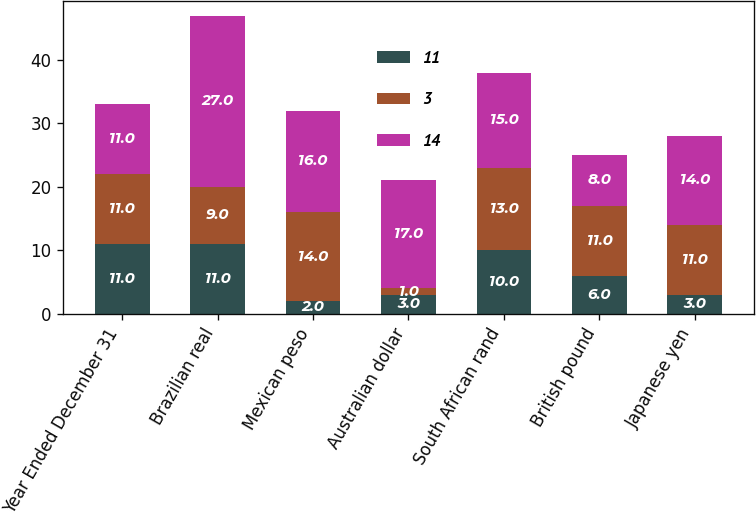Convert chart. <chart><loc_0><loc_0><loc_500><loc_500><stacked_bar_chart><ecel><fcel>Year Ended December 31<fcel>Brazilian real<fcel>Mexican peso<fcel>Australian dollar<fcel>South African rand<fcel>British pound<fcel>Japanese yen<nl><fcel>11<fcel>11<fcel>11<fcel>2<fcel>3<fcel>10<fcel>6<fcel>3<nl><fcel>3<fcel>11<fcel>9<fcel>14<fcel>1<fcel>13<fcel>11<fcel>11<nl><fcel>14<fcel>11<fcel>27<fcel>16<fcel>17<fcel>15<fcel>8<fcel>14<nl></chart> 